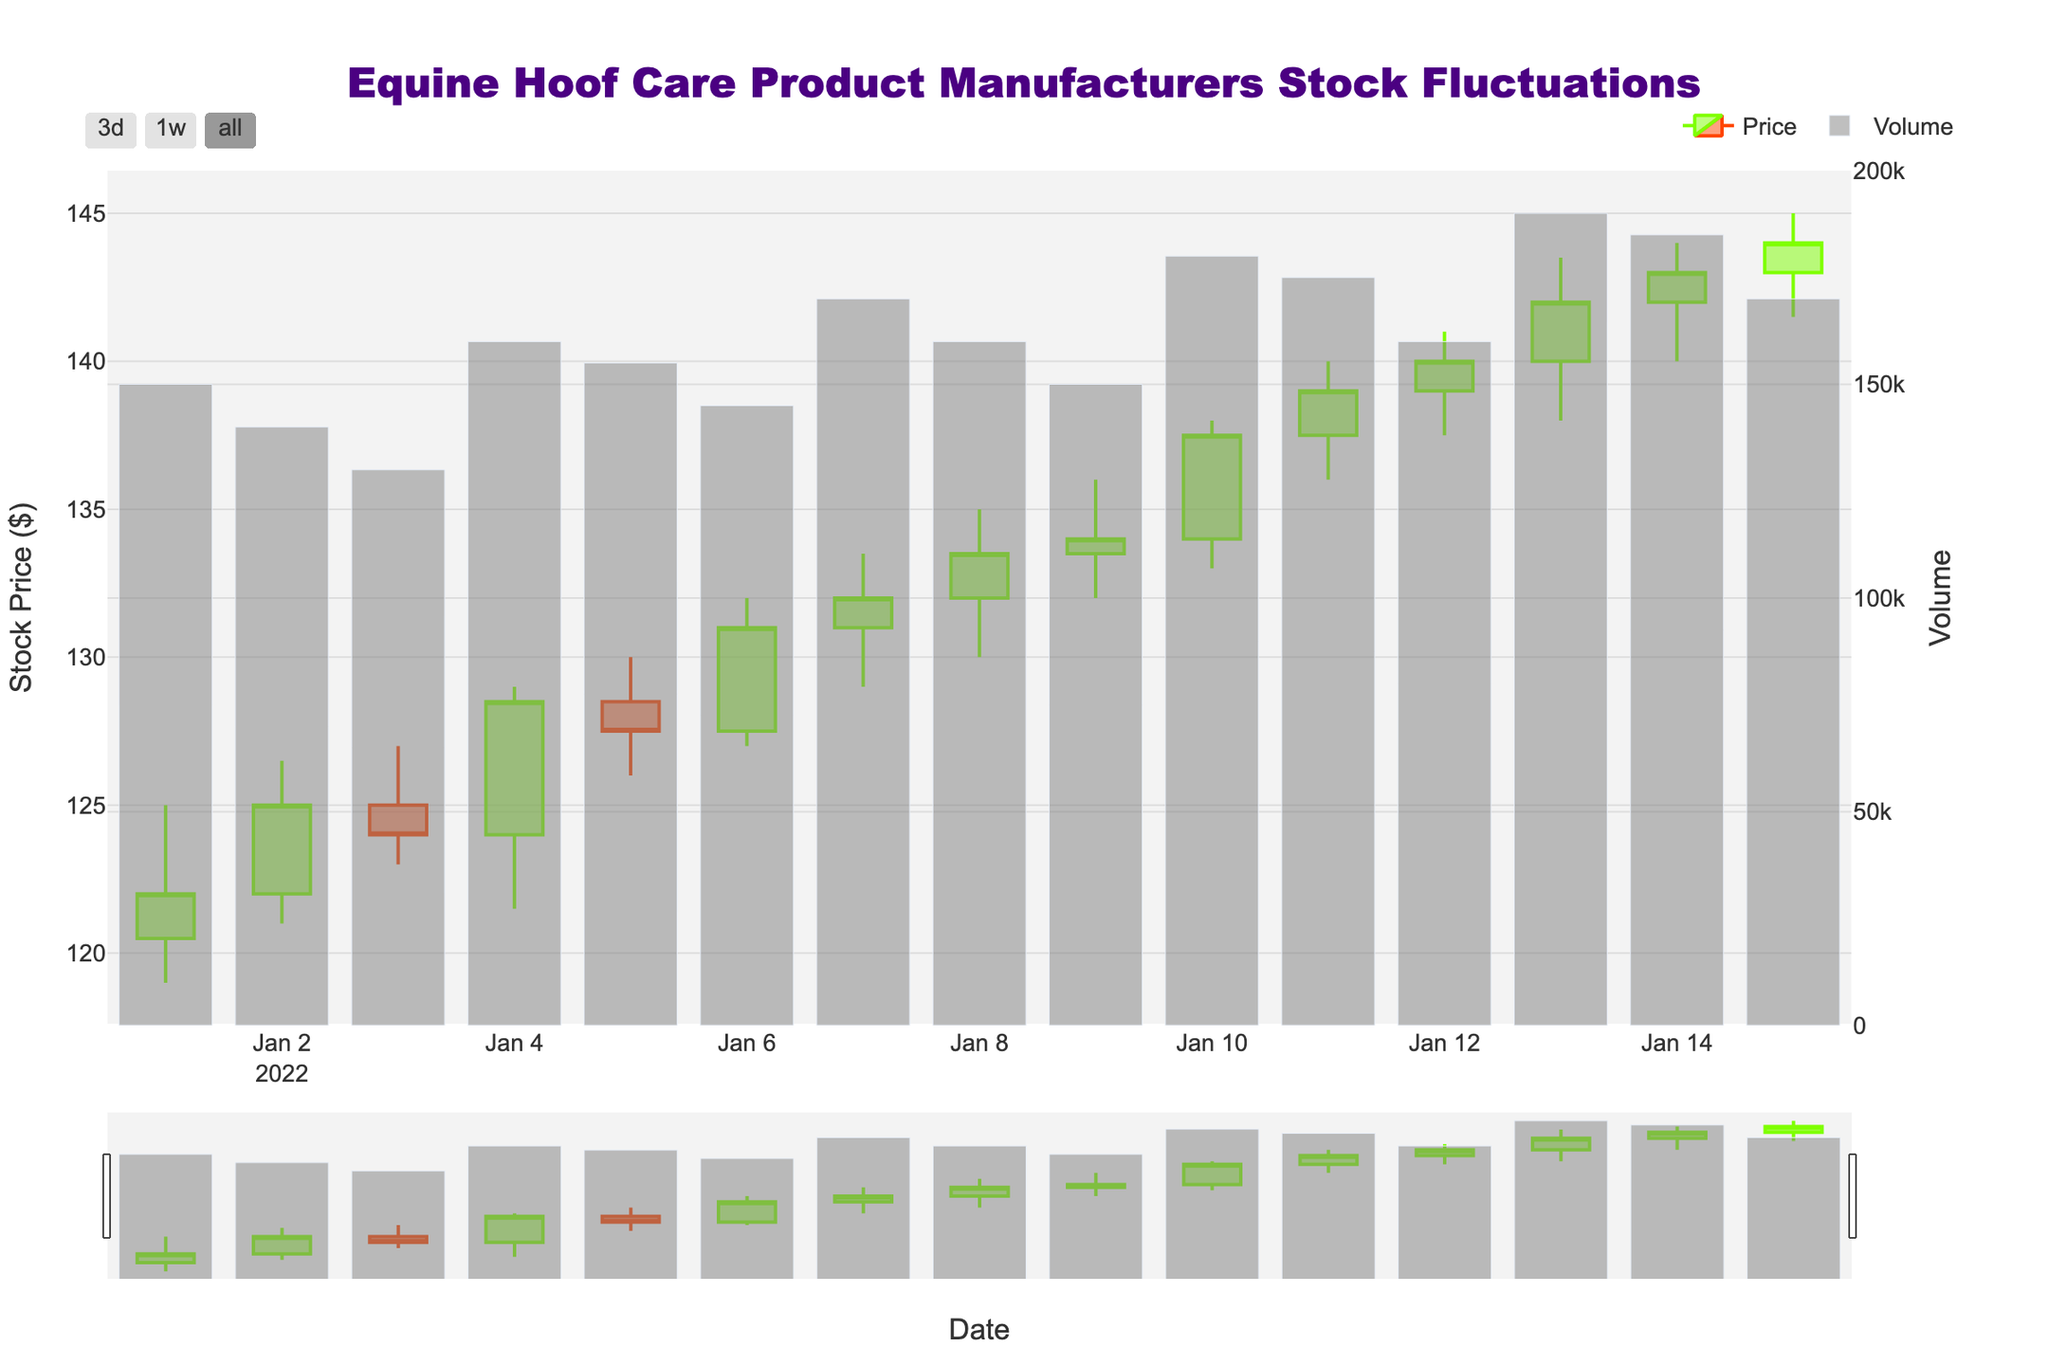What is the highest stock price reached by FarrierCare Inc. in the given period? The highest price can be found by looking at the highest point of any candlestick corresponding to FarrierCare Inc. The maximum high is on 2022-01-13 at $143.50.
Answer: $143.50 What was the opening stock price for HoofTech Solutions on 2022-01-11? Look for the candlestick corresponding to HoofTech Solutions on 2022-01-11 and identify the opening price which is listed as $137.50.
Answer: $137.50 How many days saw a volume greater than 170,000 for Equine Innovations? Identify the days for Equine Innovations and check the volume bars. Count how many bars are above the 170,000 mark. There are no days with volume greater than 170,000.
Answer: 0 days Which company had the highest closing stock price on 2022-01-10? Look at the candlestick for all companies on the date 2022-01-10 and compare the closing prices. FarrierCare Inc. had the highest closing price at $137.50.
Answer: FarrierCare Inc Which company showed the largest increase in stock price in a single day? For each company, calculate the difference between the highest and the lowest prices for each day, then find the maximum difference. FarrierCare Inc. had the largest increase from 2022-01-10 at $138.00 - $133.00 = $5.00.
Answer: FarrierCare Inc On which date did Equine Innovations have its lowest closing price? Look for the lowest closing price among Equine Innovations' candlesticks. The lowest closing price is $124.00 on 2022-01-03.
Answer: 2022-01-03 How many companies had their highest stock price close above $140 in the given period? Check the highest (close price) for all companies. All three companies had closing prices above $140.
Answer: 3 companies Between 2022-01-09 and 2022-01-12, which company saw the highest trading volume? Check the volume bars for each company during the specified dates and find the highest value. FarrierCare Inc. on 2022-01-13 had the highest volume at 190,000.
Answer: FarrierCare Inc 